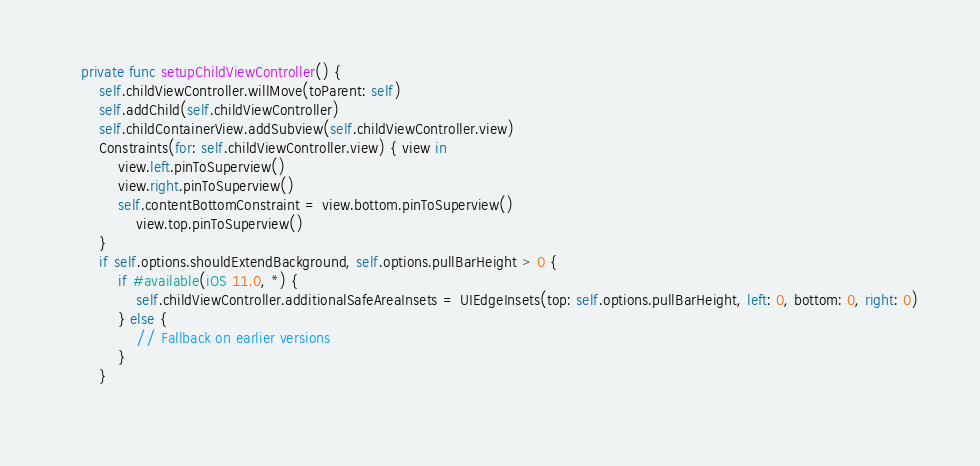<code> <loc_0><loc_0><loc_500><loc_500><_Swift_>    private func setupChildViewController() {
        self.childViewController.willMove(toParent: self)
        self.addChild(self.childViewController)
        self.childContainerView.addSubview(self.childViewController.view)
        Constraints(for: self.childViewController.view) { view in
            view.left.pinToSuperview()
            view.right.pinToSuperview()
            self.contentBottomConstraint = view.bottom.pinToSuperview()
                view.top.pinToSuperview()
        }
        if self.options.shouldExtendBackground, self.options.pullBarHeight > 0 {
            if #available(iOS 11.0, *) {
                self.childViewController.additionalSafeAreaInsets = UIEdgeInsets(top: self.options.pullBarHeight, left: 0, bottom: 0, right: 0)
            } else {
                // Fallback on earlier versions
            }
        }
        </code> 